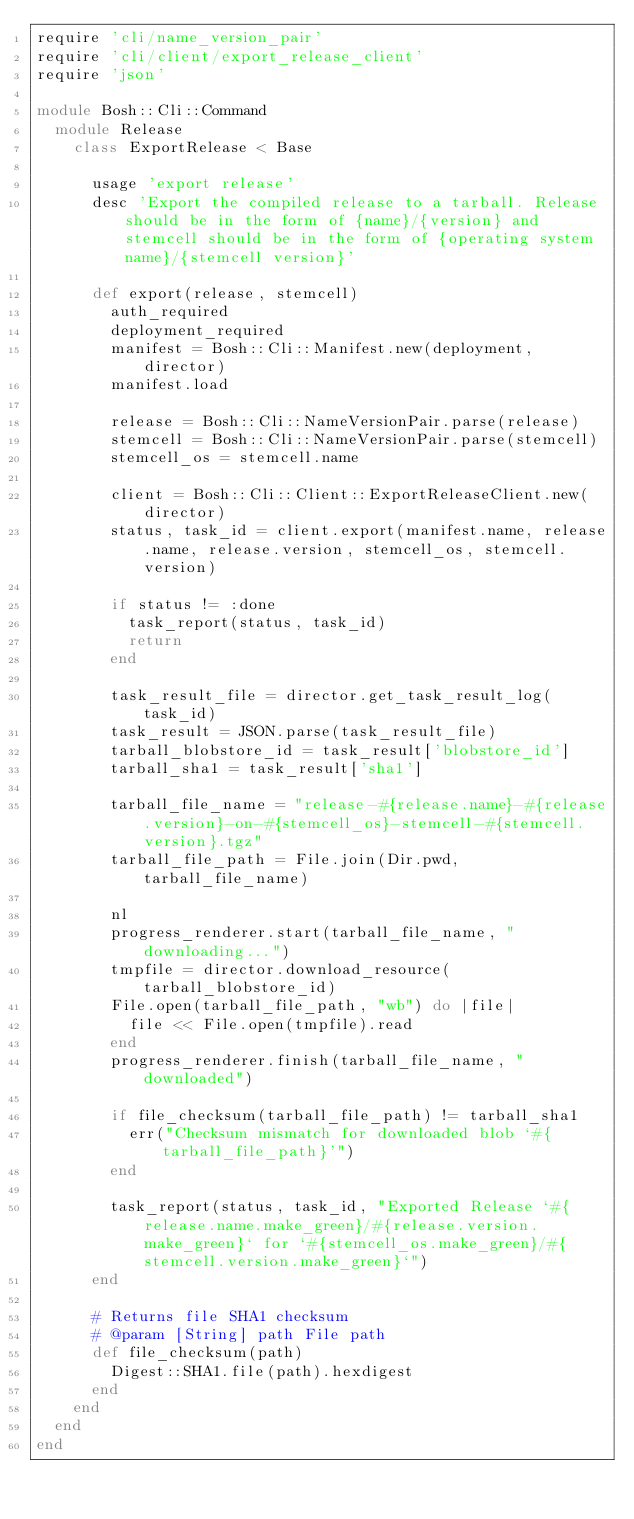<code> <loc_0><loc_0><loc_500><loc_500><_Ruby_>require 'cli/name_version_pair'
require 'cli/client/export_release_client'
require 'json'

module Bosh::Cli::Command
  module Release
    class ExportRelease < Base

      usage 'export release'
      desc 'Export the compiled release to a tarball. Release should be in the form of {name}/{version} and stemcell should be in the form of {operating system name}/{stemcell version}'

      def export(release, stemcell)
        auth_required
        deployment_required
        manifest = Bosh::Cli::Manifest.new(deployment, director)
        manifest.load

        release = Bosh::Cli::NameVersionPair.parse(release)
        stemcell = Bosh::Cli::NameVersionPair.parse(stemcell)
        stemcell_os = stemcell.name

        client = Bosh::Cli::Client::ExportReleaseClient.new(director)
        status, task_id = client.export(manifest.name, release.name, release.version, stemcell_os, stemcell.version)

        if status != :done
          task_report(status, task_id)
          return
        end

        task_result_file = director.get_task_result_log(task_id)
        task_result = JSON.parse(task_result_file)
        tarball_blobstore_id = task_result['blobstore_id']
        tarball_sha1 = task_result['sha1']

        tarball_file_name = "release-#{release.name}-#{release.version}-on-#{stemcell_os}-stemcell-#{stemcell.version}.tgz"
        tarball_file_path = File.join(Dir.pwd, tarball_file_name)

        nl
        progress_renderer.start(tarball_file_name, "downloading...")
        tmpfile = director.download_resource(tarball_blobstore_id)
        File.open(tarball_file_path, "wb") do |file|
          file << File.open(tmpfile).read
        end
        progress_renderer.finish(tarball_file_name, "downloaded")

        if file_checksum(tarball_file_path) != tarball_sha1
          err("Checksum mismatch for downloaded blob `#{tarball_file_path}'")
        end

        task_report(status, task_id, "Exported Release `#{release.name.make_green}/#{release.version.make_green}` for `#{stemcell_os.make_green}/#{stemcell.version.make_green}`")
      end

      # Returns file SHA1 checksum
      # @param [String] path File path
      def file_checksum(path)
        Digest::SHA1.file(path).hexdigest
      end
    end
  end
end
</code> 